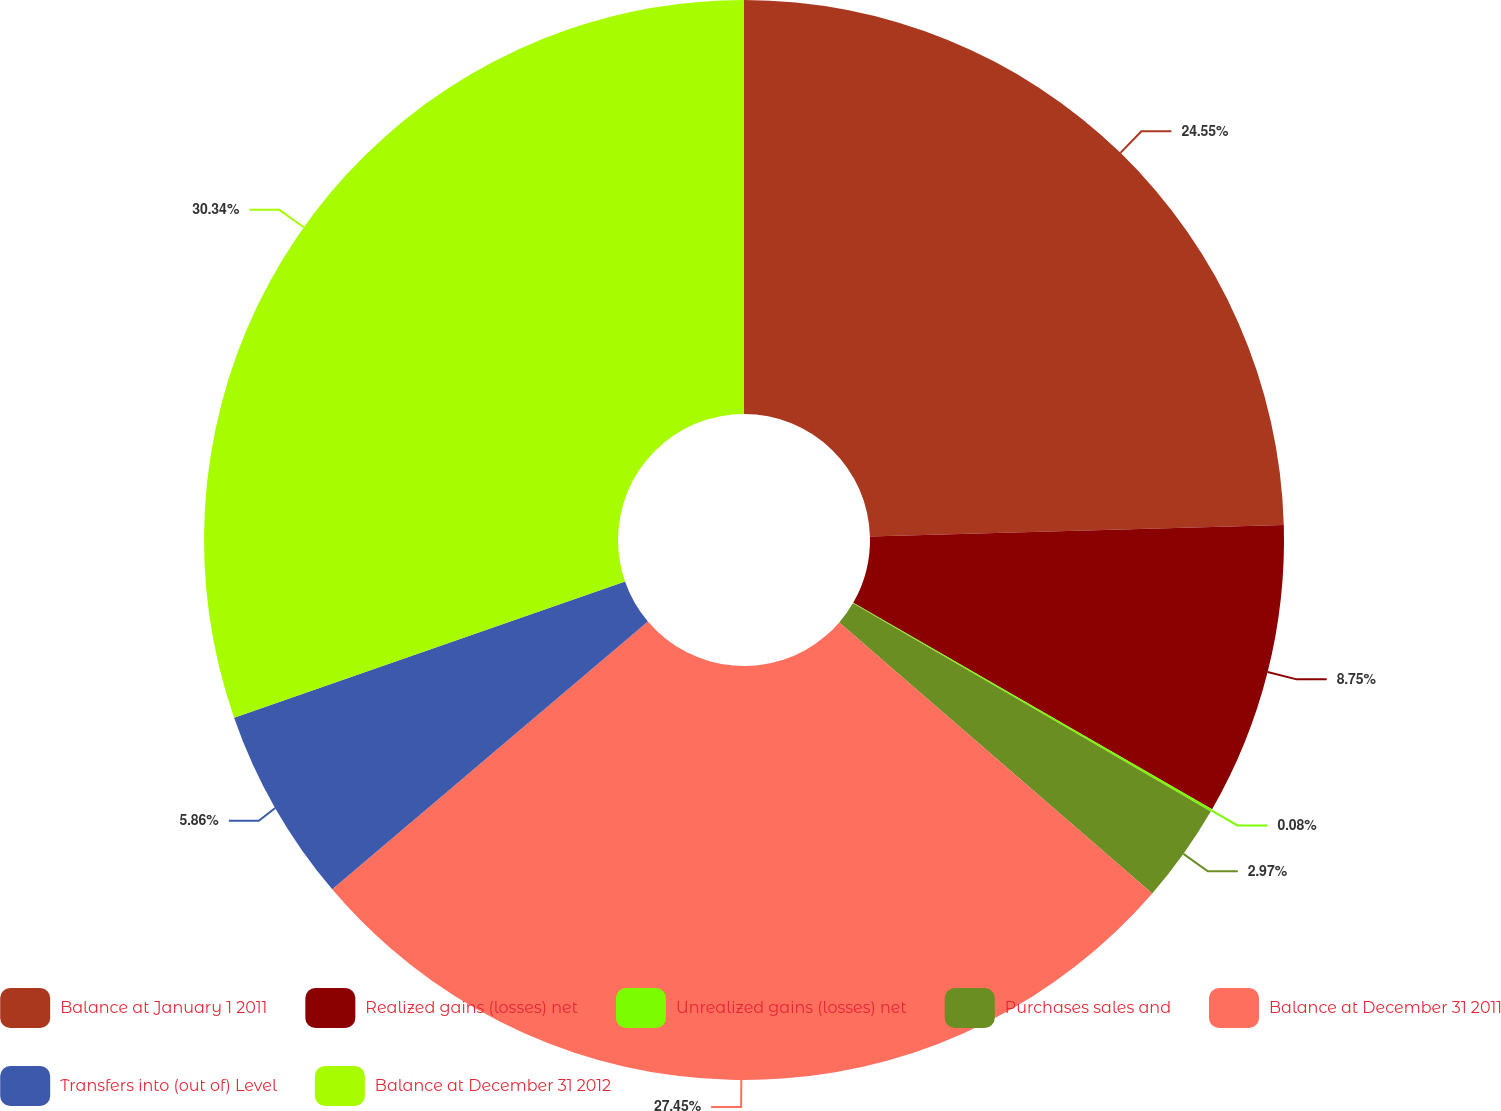Convert chart. <chart><loc_0><loc_0><loc_500><loc_500><pie_chart><fcel>Balance at January 1 2011<fcel>Realized gains (losses) net<fcel>Unrealized gains (losses) net<fcel>Purchases sales and<fcel>Balance at December 31 2011<fcel>Transfers into (out of) Level<fcel>Balance at December 31 2012<nl><fcel>24.55%<fcel>8.75%<fcel>0.08%<fcel>2.97%<fcel>27.44%<fcel>5.86%<fcel>30.33%<nl></chart> 